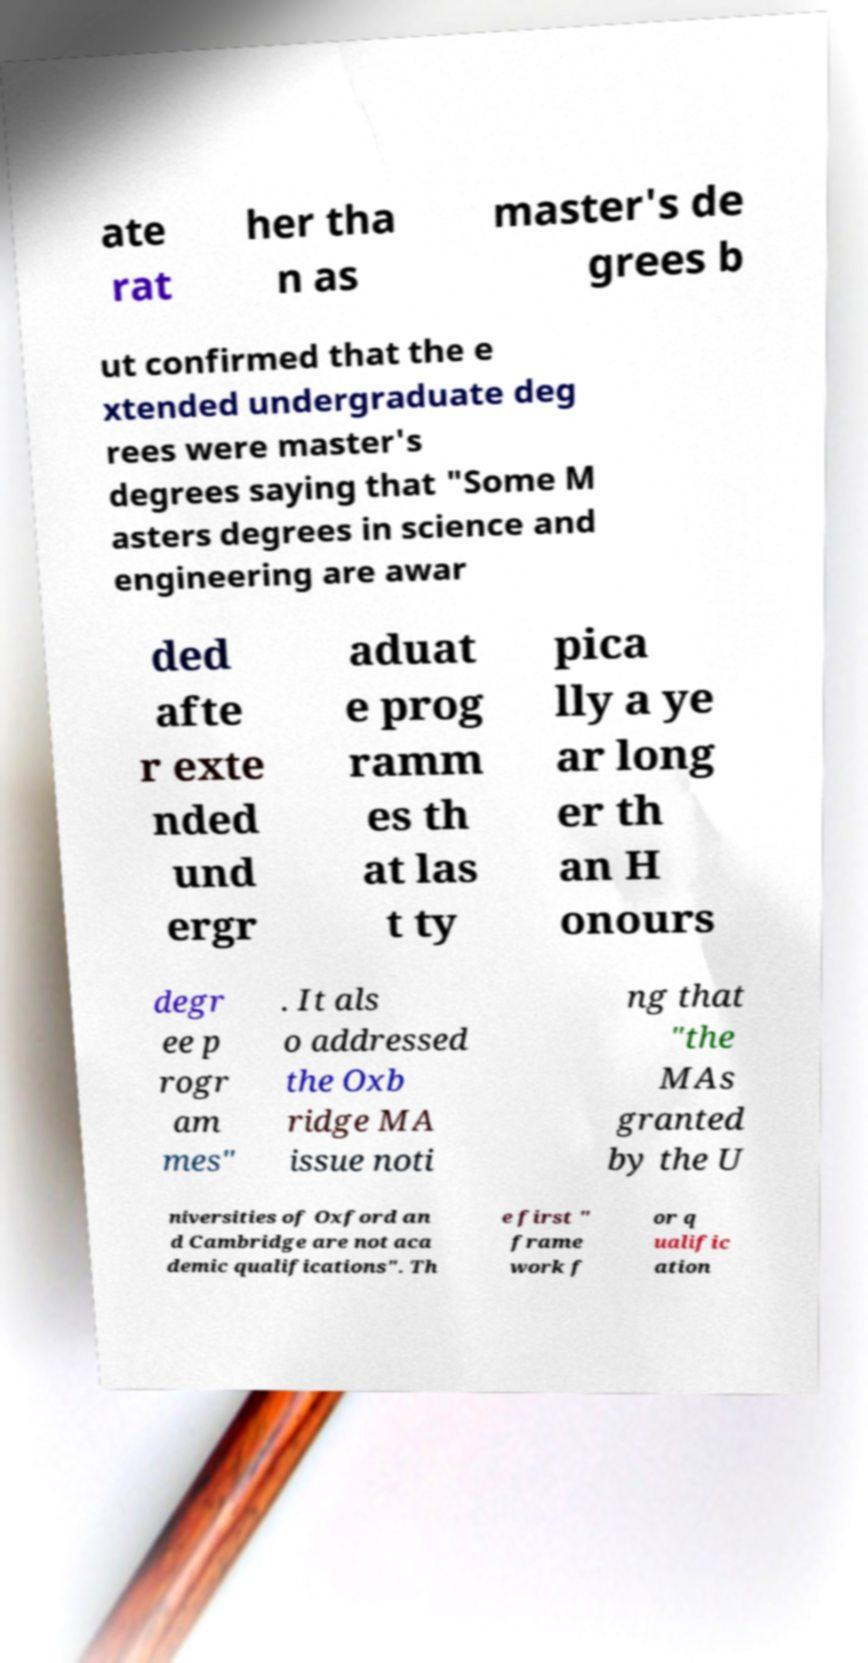Can you read and provide the text displayed in the image?This photo seems to have some interesting text. Can you extract and type it out for me? ate rat her tha n as master's de grees b ut confirmed that the e xtended undergraduate deg rees were master's degrees saying that "Some M asters degrees in science and engineering are awar ded afte r exte nded und ergr aduat e prog ramm es th at las t ty pica lly a ye ar long er th an H onours degr ee p rogr am mes" . It als o addressed the Oxb ridge MA issue noti ng that "the MAs granted by the U niversities of Oxford an d Cambridge are not aca demic qualifications". Th e first " frame work f or q ualific ation 